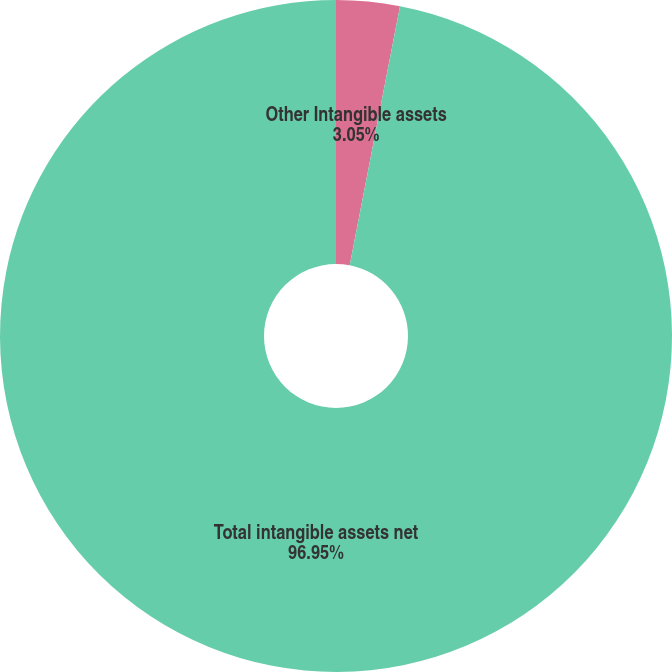<chart> <loc_0><loc_0><loc_500><loc_500><pie_chart><fcel>Other Intangible assets<fcel>Total intangible assets net<nl><fcel>3.05%<fcel>96.95%<nl></chart> 